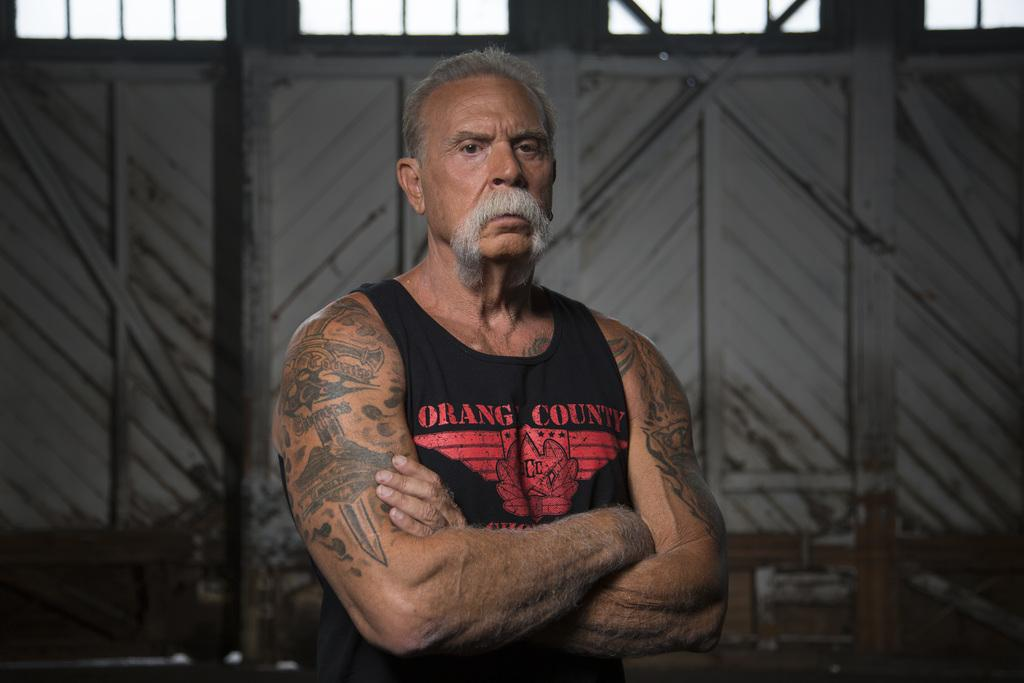Who is the main subject in the image? There is an old person with a mustache in the image. What can be seen in the background of the image? The sky is visible in the image. Can you describe any architectural features in the image? Yes, there is a door in the image. What type of jam is the old person spreading on the door in the image? There is no jam or any indication of spreading in the image; the old person is simply standing near a door. 